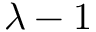Convert formula to latex. <formula><loc_0><loc_0><loc_500><loc_500>\lambda - 1</formula> 